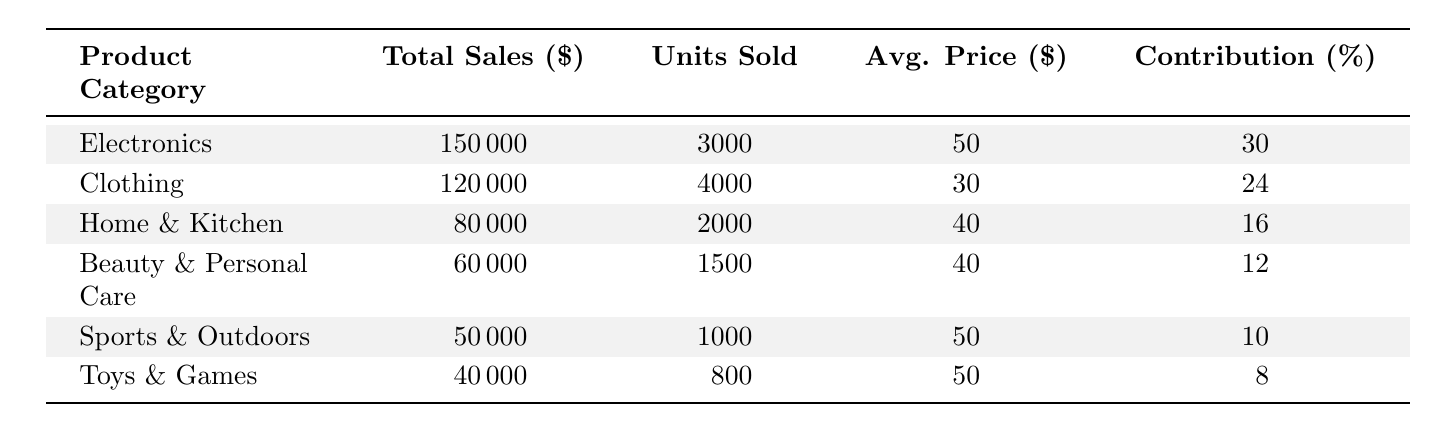What was the total sales for the Electronics category? The table shows the total sales for the Electronics category as $150,000.
Answer: 150000 Which product category sold the most units? The Clothing category sold the most units with 4,000 units sold, which is higher than all other categories.
Answer: Clothing What is the average price of products in the Home & Kitchen category? The average price for the Home & Kitchen category is listed as $40.
Answer: 40 What percentage contribution did Toys & Games make to total sales? The percentage contribution of Toys & Games is 8%, as indicated in the table.
Answer: 8 What is the difference in total sales between Electronics and Sports & Outdoors? The total sales for Electronics is $150,000 and for Sports & Outdoors is $50,000. The difference is $150,000 - $50,000 = $100,000.
Answer: 100000 What is the combined total sales for all categories? Total sales are: $150,000 (Electronics) + $120,000 (Clothing) + $80,000 (Home & Kitchen) + $60,000 (Beauty & Personal Care) + $50,000 (Sports & Outdoors) + $40,000 (Toys & Games) = $500,000.
Answer: 500000 Are there more units sold in Beauty & Personal Care than in Sports & Outdoors? Beauty & Personal Care sold 1,500 units and Sports & Outdoors sold 1,000 units, so yes, Beauty & Personal Care sold more units.
Answer: Yes What product category has the highest average price? The average price in both Electronics and Sports & Outdoors is $50, which is higher than all other categories.
Answer: Electronics and Sports & Outdoors Which category represents the least percentage contribution to total sales? The Toys & Games category has the least percentage contribution at 8%.
Answer: Toys & Games How many more units were sold in Clothing compared to Home & Kitchen? Clothing sold 4,000 units and Home & Kitchen sold 2,000 units. The difference is 4,000 - 2,000 = 2,000 units.
Answer: 2000 What is the average total sales per category? There are 6 categories, and total sales are $500,000. The average sales per category is $500,000 / 6 = $83,333.33.
Answer: 83333.33 